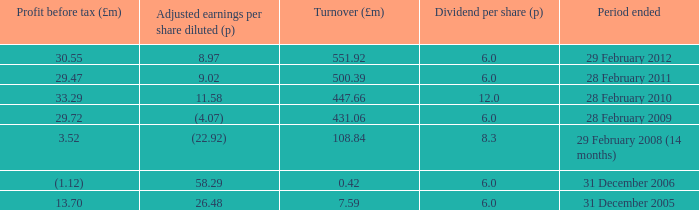How many items appear in the dividend per share when the turnover is 0.42? 1.0. 